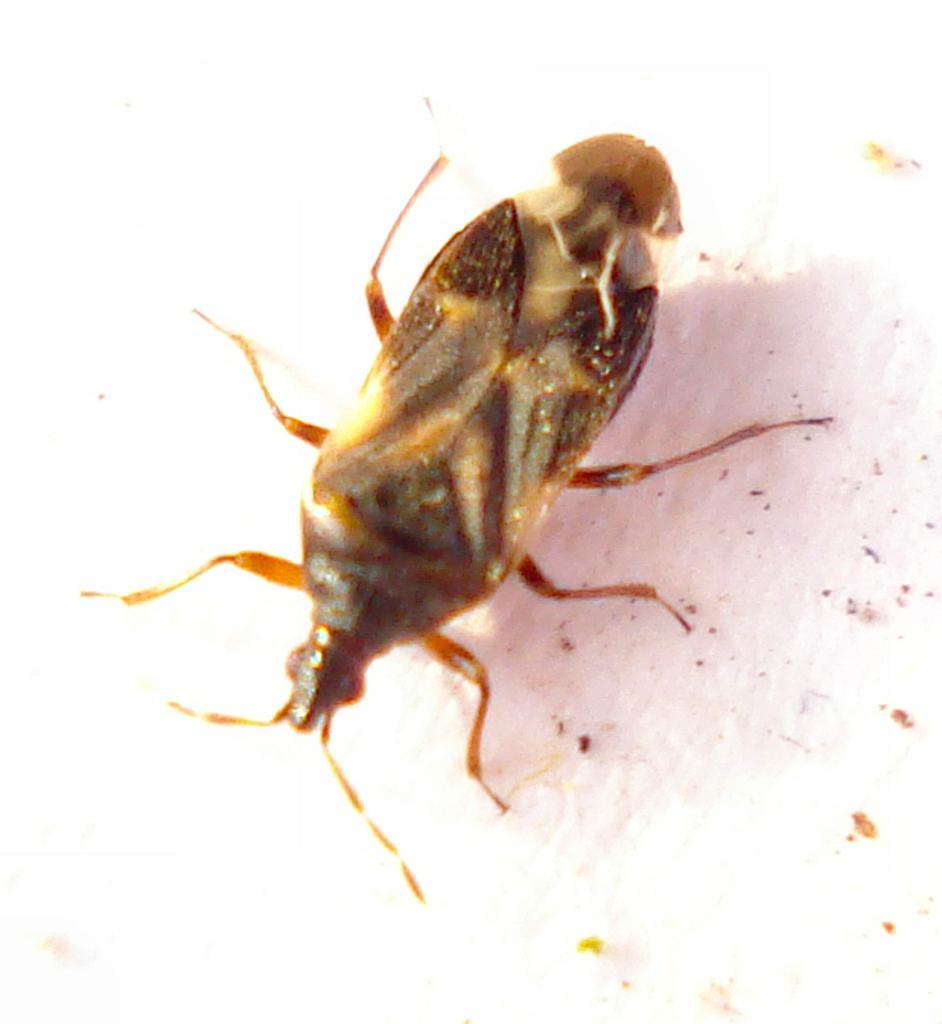Please provide a concise description of this image. Here we can see an insect on a platform. 